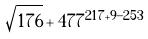Convert formula to latex. <formula><loc_0><loc_0><loc_500><loc_500>\sqrt { 1 7 6 } + 4 7 7 ^ { 2 1 7 + 9 - 2 5 3 }</formula> 